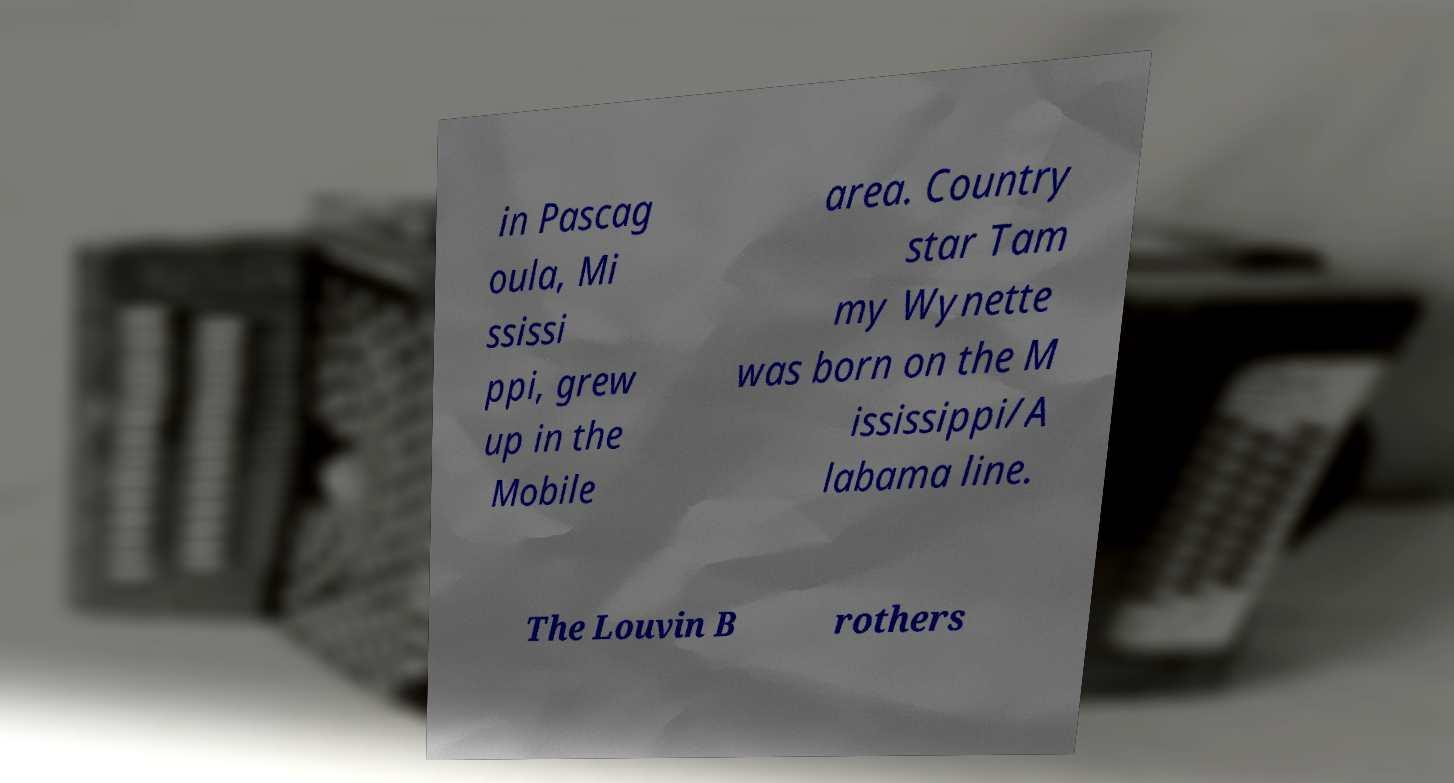Please identify and transcribe the text found in this image. in Pascag oula, Mi ssissi ppi, grew up in the Mobile area. Country star Tam my Wynette was born on the M ississippi/A labama line. The Louvin B rothers 